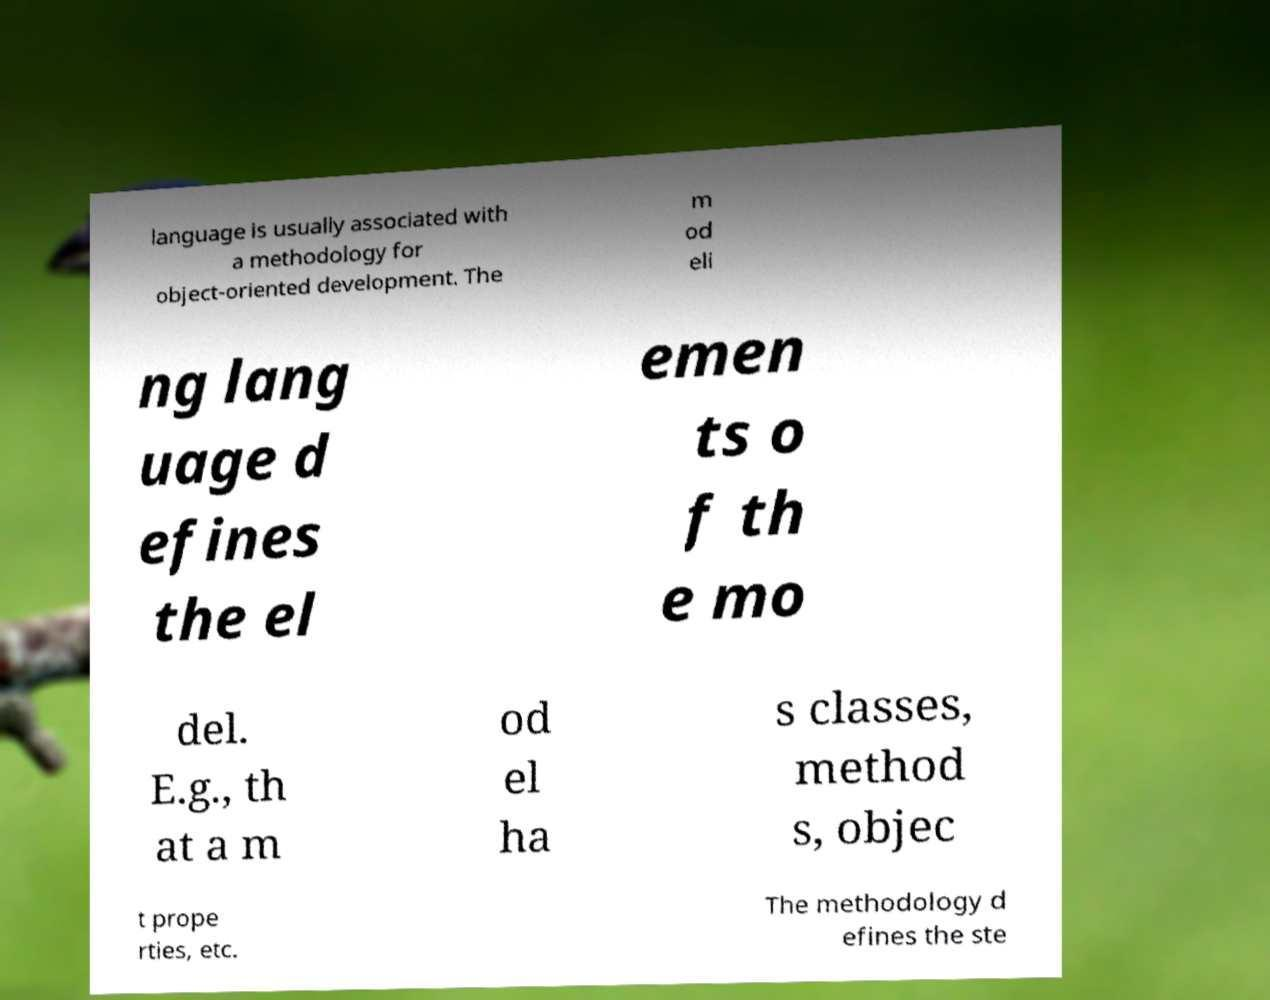Could you extract and type out the text from this image? language is usually associated with a methodology for object-oriented development. The m od eli ng lang uage d efines the el emen ts o f th e mo del. E.g., th at a m od el ha s classes, method s, objec t prope rties, etc. The methodology d efines the ste 